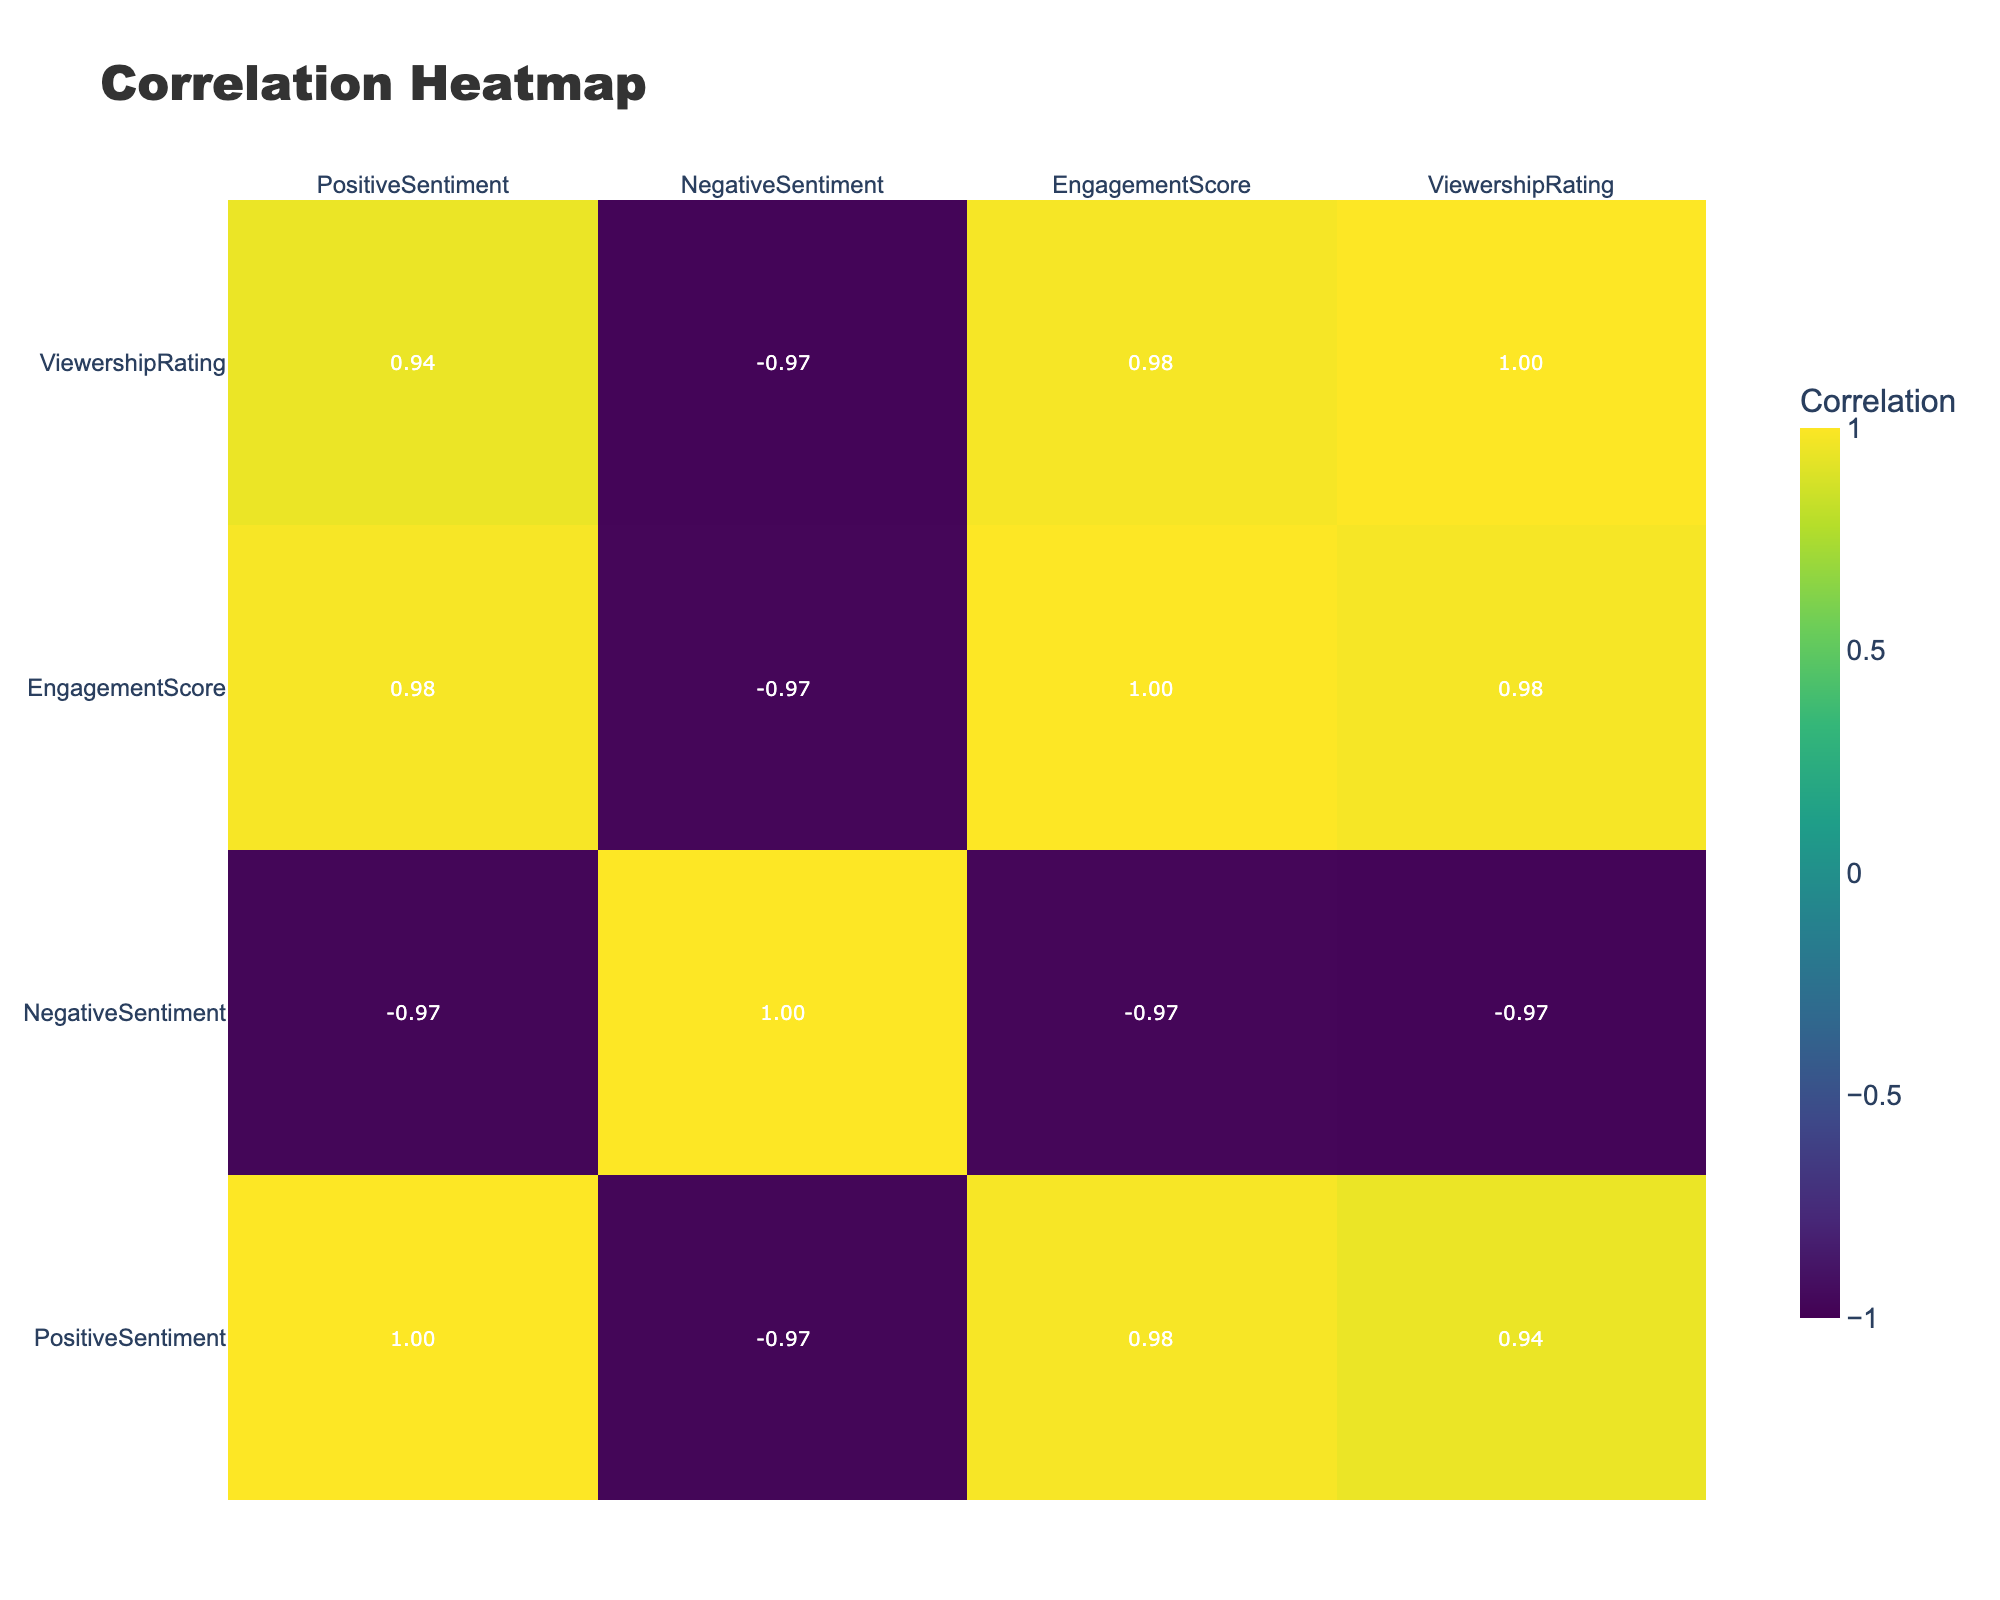What is the viewership rating of the pairing Emily & Jack? The viewership rating for Emily & Jack is listed in the table under the 'ViewershipRating' column, where it is recorded as 9.2.
Answer: 9.2 Which on-screen pair has the highest engagement score? By looking at the 'EngagementScore' column, Chloe & Noah have the highest score at 900, which is higher than all other pairs.
Answer: Chloe & Noah Is there a negative sentiment value greater than 0.10 among the on-screen pairs? Checking the 'NegativeSentiment' column, we find that 'Mia & Alex' has a value of 0.15 and 'Ava & Lucas' has 0.14, both are greater than 0.10.
Answer: Yes What is the average positive sentiment across all pairs? To find the average, sum all the 'PositiveSentiment' values: 0.75 + 0.60 + 0.80 + 0.55 + 0.70 + 0.65 + 0.82 + 0.58 + 0.73 + 0.62 = 7.40. Divide by the number of pairs (10), we get 7.40/10 = 0.74.
Answer: 0.74 Is the engagement score of the pair with the highest positive sentiment also the highest overall? The pair with the highest positive sentiment is Isabella & Daniel with a value of 0.82, but their engagement score is 930, which is not higher than Chloe & Noah's engagement score of 900. Thus, the statement is false.
Answer: No What is the difference in viewership rating between the pair with the highest engagement score and the pair with the lowest engagement score? The highest engagement score is 930 for Isabella & Daniel and the lowest is 650 for Mia & Alex. The viewership ratings are 9.6 and 8.3 respectively. The difference is 9.6 - 8.3 = 1.3.
Answer: 1.3 Which on-screen pair has the lowest positive sentiment and what is that value? The lowest positive sentiment value is listed for Mia & Alex in the 'PositiveSentiment' column, which shows 0.55.
Answer: Mia & Alex, 0.55 What is the correlation between positive sentiment and engagement score? By looking at the correlation table, we find the correlation coefficient between 'PositiveSentiment' and 'EngagementScore' to be 0.87, indicating a strong positive correlation.
Answer: 0.87 Is there an on-screen pair with negative sentiment lower than 0.05? By examining the 'NegativeSentiment' column, we see that no pair has a negative sentiment lower than 0.05, as the lowest is 0.02 for Chloe & Noah.
Answer: No 